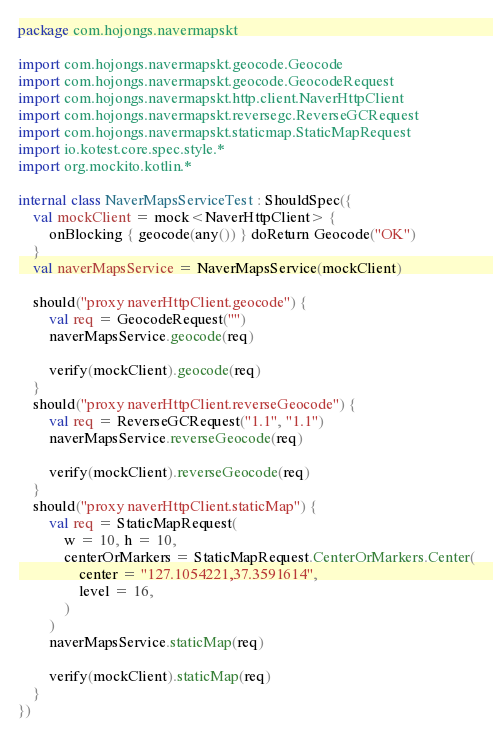<code> <loc_0><loc_0><loc_500><loc_500><_Kotlin_>package com.hojongs.navermapskt

import com.hojongs.navermapskt.geocode.Geocode
import com.hojongs.navermapskt.geocode.GeocodeRequest
import com.hojongs.navermapskt.http.client.NaverHttpClient
import com.hojongs.navermapskt.reversegc.ReverseGCRequest
import com.hojongs.navermapskt.staticmap.StaticMapRequest
import io.kotest.core.spec.style.*
import org.mockito.kotlin.*

internal class NaverMapsServiceTest : ShouldSpec({
    val mockClient = mock<NaverHttpClient> {
        onBlocking { geocode(any()) } doReturn Geocode("OK")
    }
    val naverMapsService = NaverMapsService(mockClient)

    should("proxy naverHttpClient.geocode") {
        val req = GeocodeRequest("")
        naverMapsService.geocode(req)

        verify(mockClient).geocode(req)
    }
    should("proxy naverHttpClient.reverseGeocode") {
        val req = ReverseGCRequest("1.1", "1.1")
        naverMapsService.reverseGeocode(req)

        verify(mockClient).reverseGeocode(req)
    }
    should("proxy naverHttpClient.staticMap") {
        val req = StaticMapRequest(
            w = 10, h = 10,
            centerOrMarkers = StaticMapRequest.CenterOrMarkers.Center(
                center = "127.1054221,37.3591614",
                level = 16,
            )
        )
        naverMapsService.staticMap(req)

        verify(mockClient).staticMap(req)
    }
})
</code> 